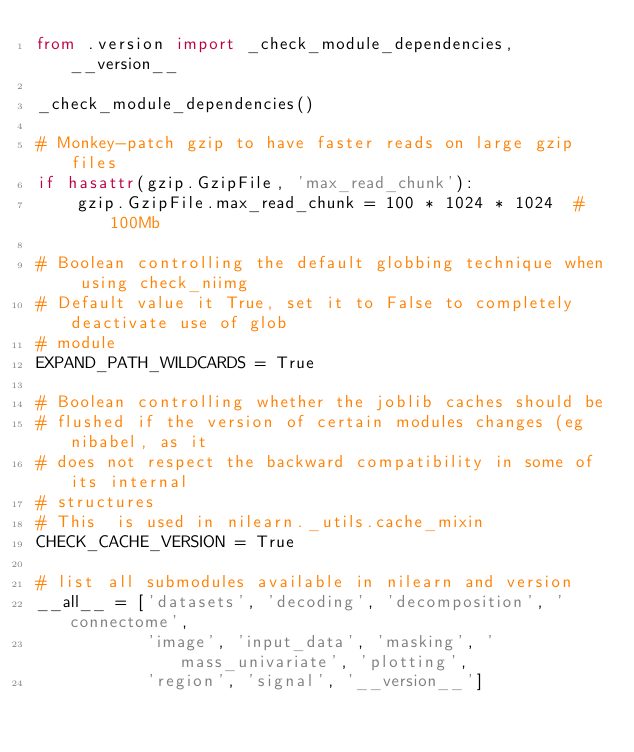Convert code to text. <code><loc_0><loc_0><loc_500><loc_500><_Python_>from .version import _check_module_dependencies, __version__

_check_module_dependencies()

# Monkey-patch gzip to have faster reads on large gzip files
if hasattr(gzip.GzipFile, 'max_read_chunk'):
    gzip.GzipFile.max_read_chunk = 100 * 1024 * 1024  # 100Mb

# Boolean controlling the default globbing technique when using check_niimg
# Default value it True, set it to False to completely deactivate use of glob
# module
EXPAND_PATH_WILDCARDS = True

# Boolean controlling whether the joblib caches should be
# flushed if the version of certain modules changes (eg nibabel, as it
# does not respect the backward compatibility in some of its internal
# structures
# This  is used in nilearn._utils.cache_mixin
CHECK_CACHE_VERSION = True

# list all submodules available in nilearn and version
__all__ = ['datasets', 'decoding', 'decomposition', 'connectome',
           'image', 'input_data', 'masking', 'mass_univariate', 'plotting',
           'region', 'signal', '__version__']
</code> 